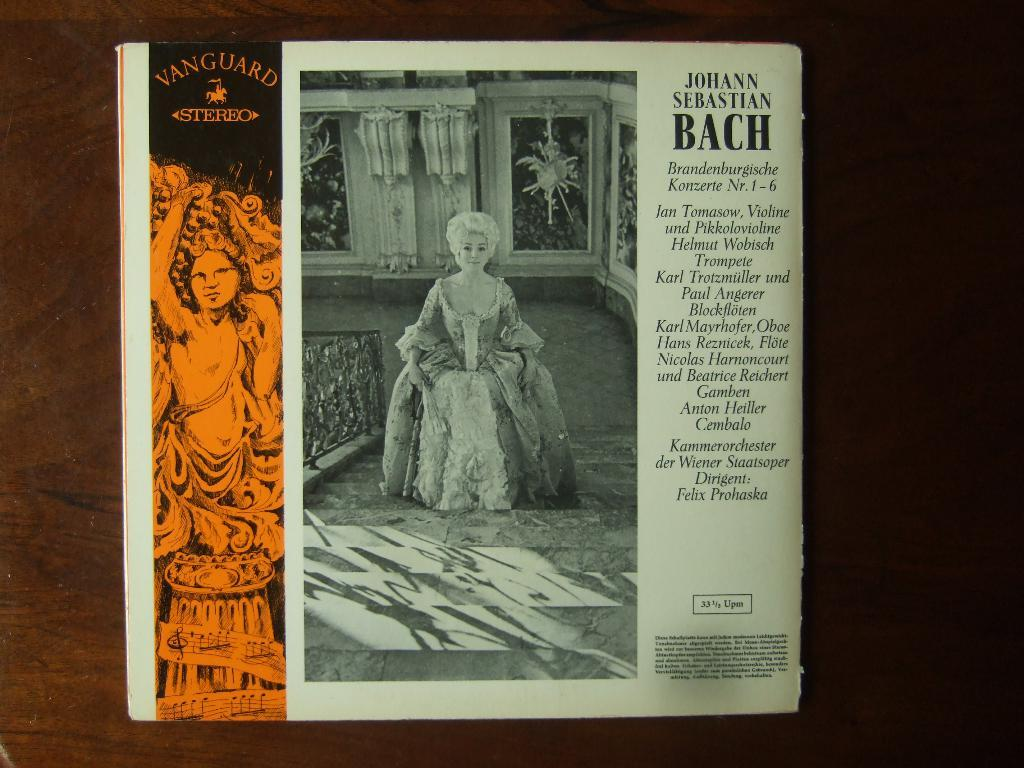<image>
Write a terse but informative summary of the picture. An older record album contains music by Bach. 